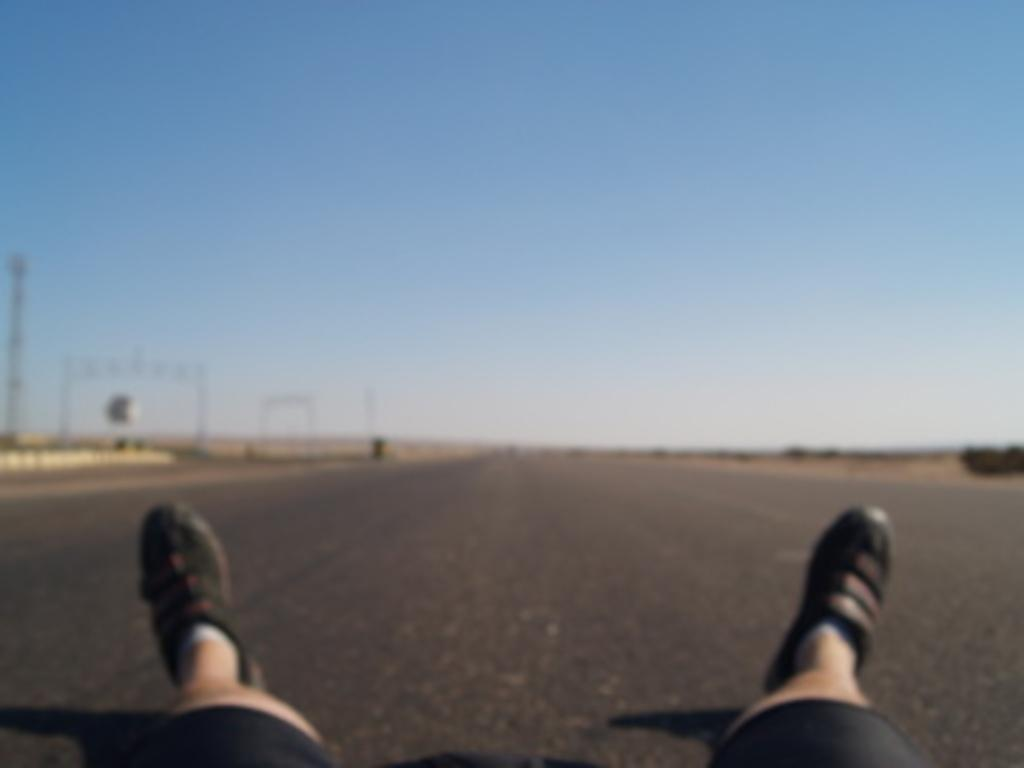What body parts can be seen in the image? Human legs with shoes are visible in the image. Where are the legs located in the image? The legs are at the bottom of the image. What type of surface is present in the image? The image contains a road. What is visible at the top of the image? The sky is visible at the top of the image. What color is the sky in the image? The sky is blue in color. What type of pencil is being used for observation in the image? There is no pencil or observation activity present in the image. How is the steam being produced in the image? There is no steam present in the image. 